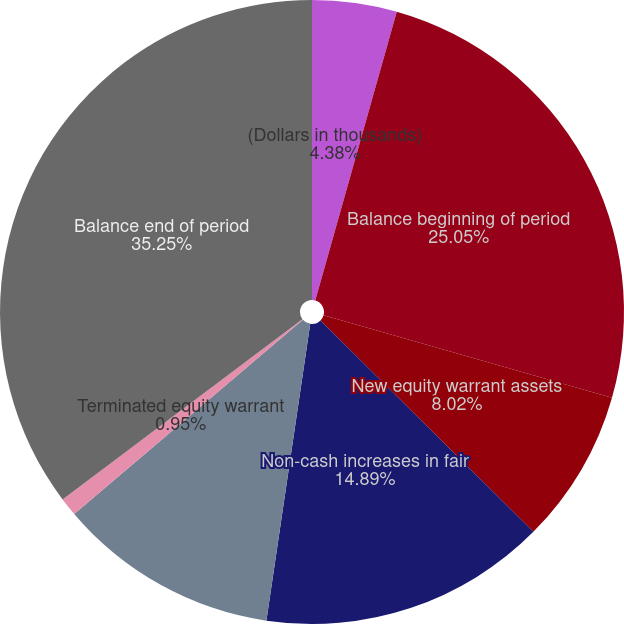Convert chart. <chart><loc_0><loc_0><loc_500><loc_500><pie_chart><fcel>(Dollars in thousands)<fcel>Balance beginning of period<fcel>New equity warrant assets<fcel>Non-cash increases in fair<fcel>Exercised equity warrant<fcel>Terminated equity warrant<fcel>Balance end of period<nl><fcel>4.38%<fcel>25.05%<fcel>8.02%<fcel>14.89%<fcel>11.46%<fcel>0.95%<fcel>35.26%<nl></chart> 